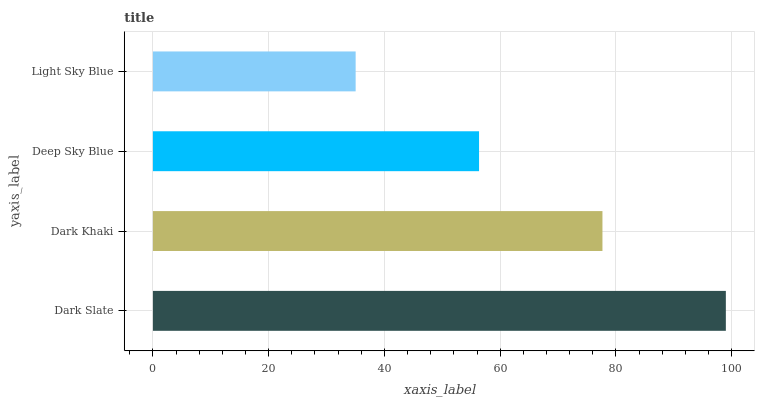Is Light Sky Blue the minimum?
Answer yes or no. Yes. Is Dark Slate the maximum?
Answer yes or no. Yes. Is Dark Khaki the minimum?
Answer yes or no. No. Is Dark Khaki the maximum?
Answer yes or no. No. Is Dark Slate greater than Dark Khaki?
Answer yes or no. Yes. Is Dark Khaki less than Dark Slate?
Answer yes or no. Yes. Is Dark Khaki greater than Dark Slate?
Answer yes or no. No. Is Dark Slate less than Dark Khaki?
Answer yes or no. No. Is Dark Khaki the high median?
Answer yes or no. Yes. Is Deep Sky Blue the low median?
Answer yes or no. Yes. Is Deep Sky Blue the high median?
Answer yes or no. No. Is Dark Khaki the low median?
Answer yes or no. No. 